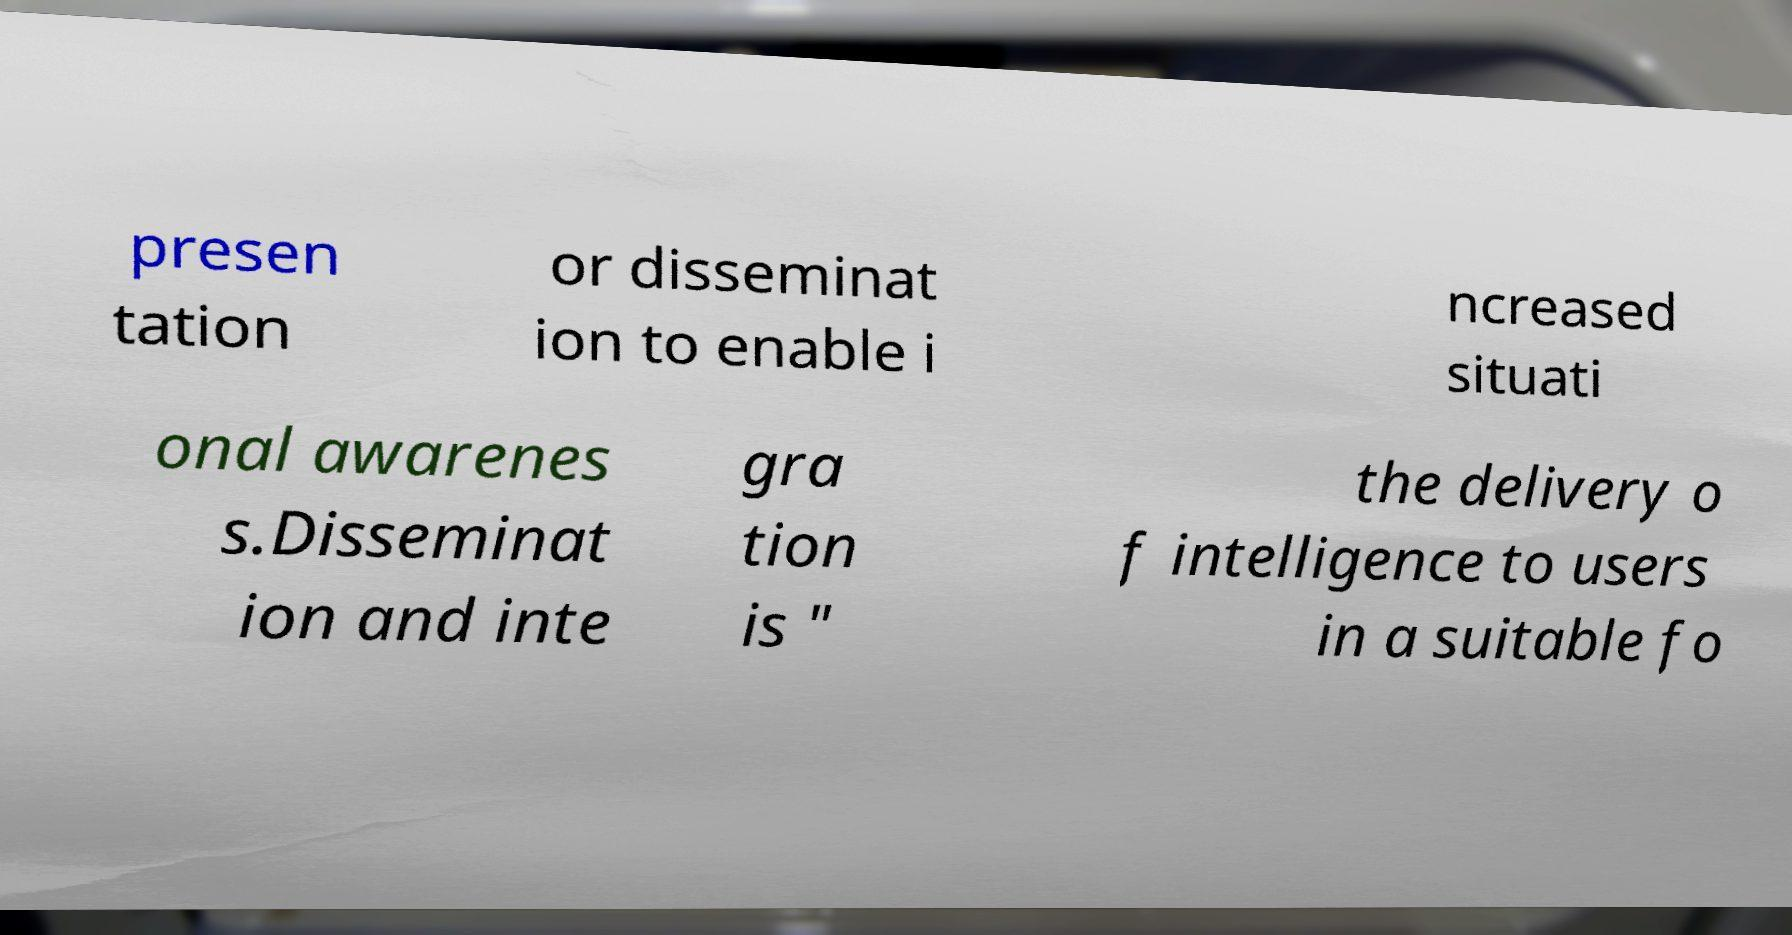Please identify and transcribe the text found in this image. presen tation or disseminat ion to enable i ncreased situati onal awarenes s.Disseminat ion and inte gra tion is " the delivery o f intelligence to users in a suitable fo 